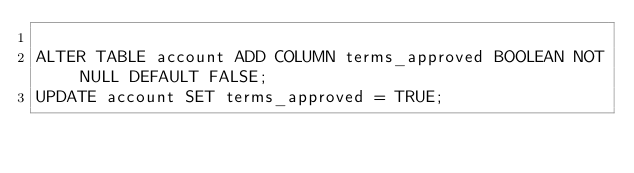<code> <loc_0><loc_0><loc_500><loc_500><_SQL_>
ALTER TABLE account ADD COLUMN terms_approved BOOLEAN NOT NULL DEFAULT FALSE;
UPDATE account SET terms_approved = TRUE;
</code> 